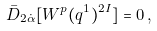<formula> <loc_0><loc_0><loc_500><loc_500>\bar { D } _ { 2 \dot { \alpha } } [ W ^ { p } ( q ^ { 1 } ) ^ { 2 I } ] = 0 \, ,</formula> 